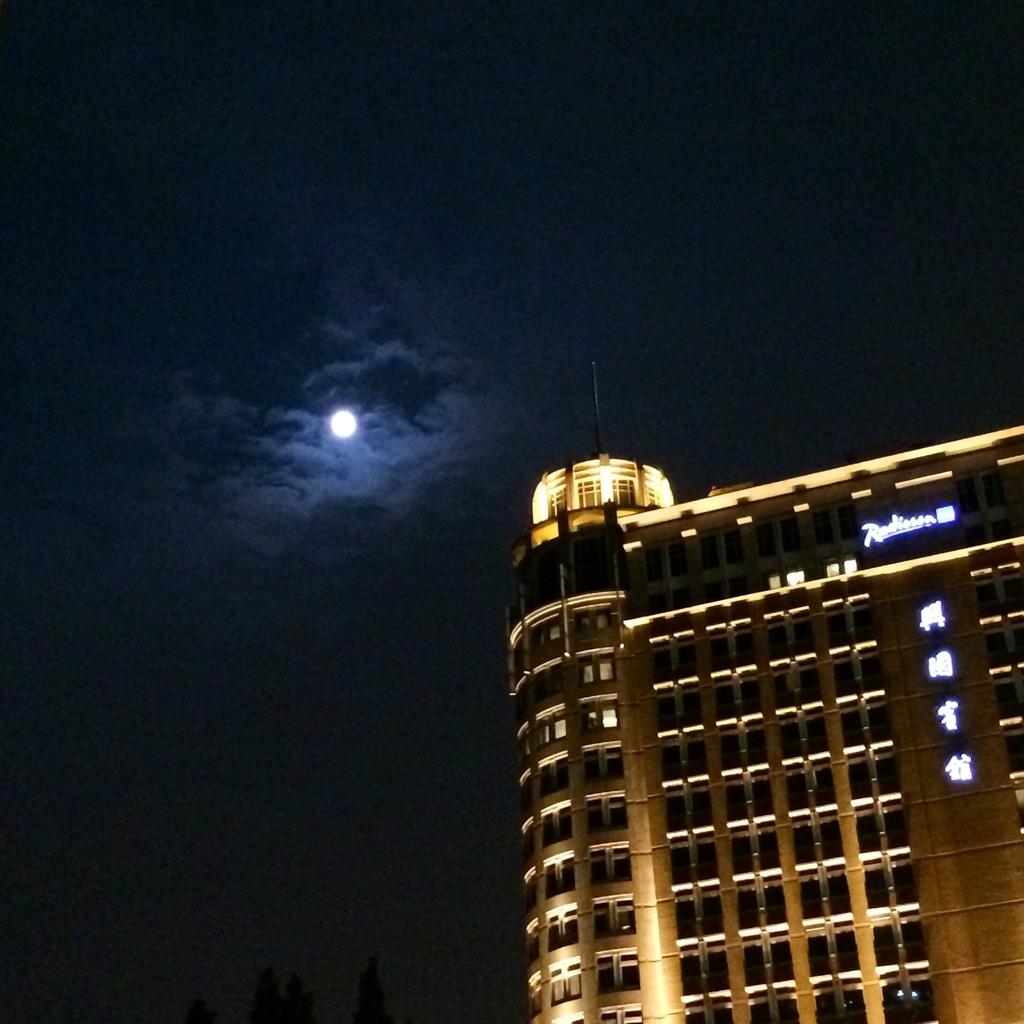What type of structure is present in the image? There is a building in the image. What can be seen on the building? There is text written on the building. What part of the natural environment is visible in the image? The sky is visible in the image. What celestial body can be seen in the sky? There is a moon in the sky. What type of drug is being sold at the building in the image? There is no indication in the building in the image is selling any drugs, and therefore it cannot be determined from the image. 